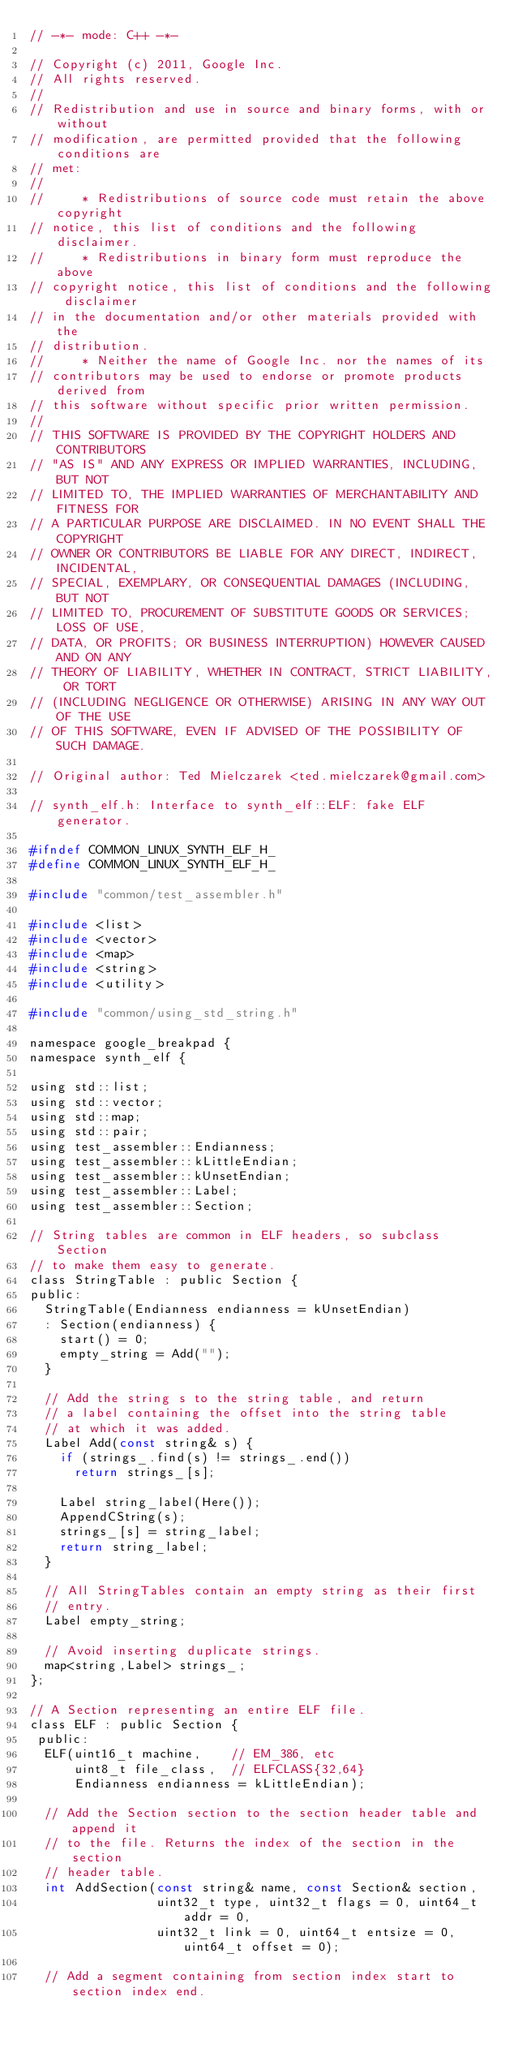Convert code to text. <code><loc_0><loc_0><loc_500><loc_500><_C_>// -*- mode: C++ -*-

// Copyright (c) 2011, Google Inc.
// All rights reserved.
//
// Redistribution and use in source and binary forms, with or without
// modification, are permitted provided that the following conditions are
// met:
//
//     * Redistributions of source code must retain the above copyright
// notice, this list of conditions and the following disclaimer.
//     * Redistributions in binary form must reproduce the above
// copyright notice, this list of conditions and the following disclaimer
// in the documentation and/or other materials provided with the
// distribution.
//     * Neither the name of Google Inc. nor the names of its
// contributors may be used to endorse or promote products derived from
// this software without specific prior written permission.
//
// THIS SOFTWARE IS PROVIDED BY THE COPYRIGHT HOLDERS AND CONTRIBUTORS
// "AS IS" AND ANY EXPRESS OR IMPLIED WARRANTIES, INCLUDING, BUT NOT
// LIMITED TO, THE IMPLIED WARRANTIES OF MERCHANTABILITY AND FITNESS FOR
// A PARTICULAR PURPOSE ARE DISCLAIMED. IN NO EVENT SHALL THE COPYRIGHT
// OWNER OR CONTRIBUTORS BE LIABLE FOR ANY DIRECT, INDIRECT, INCIDENTAL,
// SPECIAL, EXEMPLARY, OR CONSEQUENTIAL DAMAGES (INCLUDING, BUT NOT
// LIMITED TO, PROCUREMENT OF SUBSTITUTE GOODS OR SERVICES; LOSS OF USE,
// DATA, OR PROFITS; OR BUSINESS INTERRUPTION) HOWEVER CAUSED AND ON ANY
// THEORY OF LIABILITY, WHETHER IN CONTRACT, STRICT LIABILITY, OR TORT
// (INCLUDING NEGLIGENCE OR OTHERWISE) ARISING IN ANY WAY OUT OF THE USE
// OF THIS SOFTWARE, EVEN IF ADVISED OF THE POSSIBILITY OF SUCH DAMAGE.

// Original author: Ted Mielczarek <ted.mielczarek@gmail.com>

// synth_elf.h: Interface to synth_elf::ELF: fake ELF generator.

#ifndef COMMON_LINUX_SYNTH_ELF_H_
#define COMMON_LINUX_SYNTH_ELF_H_

#include "common/test_assembler.h"

#include <list>
#include <vector>
#include <map>
#include <string>
#include <utility>

#include "common/using_std_string.h"

namespace google_breakpad {
namespace synth_elf {

using std::list;
using std::vector;
using std::map;
using std::pair;
using test_assembler::Endianness;
using test_assembler::kLittleEndian;
using test_assembler::kUnsetEndian;
using test_assembler::Label;
using test_assembler::Section;

// String tables are common in ELF headers, so subclass Section
// to make them easy to generate.
class StringTable : public Section {
public:
  StringTable(Endianness endianness = kUnsetEndian)
  : Section(endianness) {
    start() = 0;
    empty_string = Add("");
  }

  // Add the string s to the string table, and return
  // a label containing the offset into the string table
  // at which it was added.
  Label Add(const string& s) {
    if (strings_.find(s) != strings_.end())
      return strings_[s];

    Label string_label(Here());
    AppendCString(s);
    strings_[s] = string_label;
    return string_label;
  }

  // All StringTables contain an empty string as their first
  // entry.
  Label empty_string;

  // Avoid inserting duplicate strings.
  map<string,Label> strings_;
};

// A Section representing an entire ELF file.
class ELF : public Section {
 public:
  ELF(uint16_t machine,    // EM_386, etc
      uint8_t file_class,  // ELFCLASS{32,64}
      Endianness endianness = kLittleEndian);

  // Add the Section section to the section header table and append it
  // to the file. Returns the index of the section in the section
  // header table.
  int AddSection(const string& name, const Section& section,
                 uint32_t type, uint32_t flags = 0, uint64_t addr = 0,
                 uint32_t link = 0, uint64_t entsize = 0, uint64_t offset = 0);
                  
  // Add a segment containing from section index start to section index end.</code> 